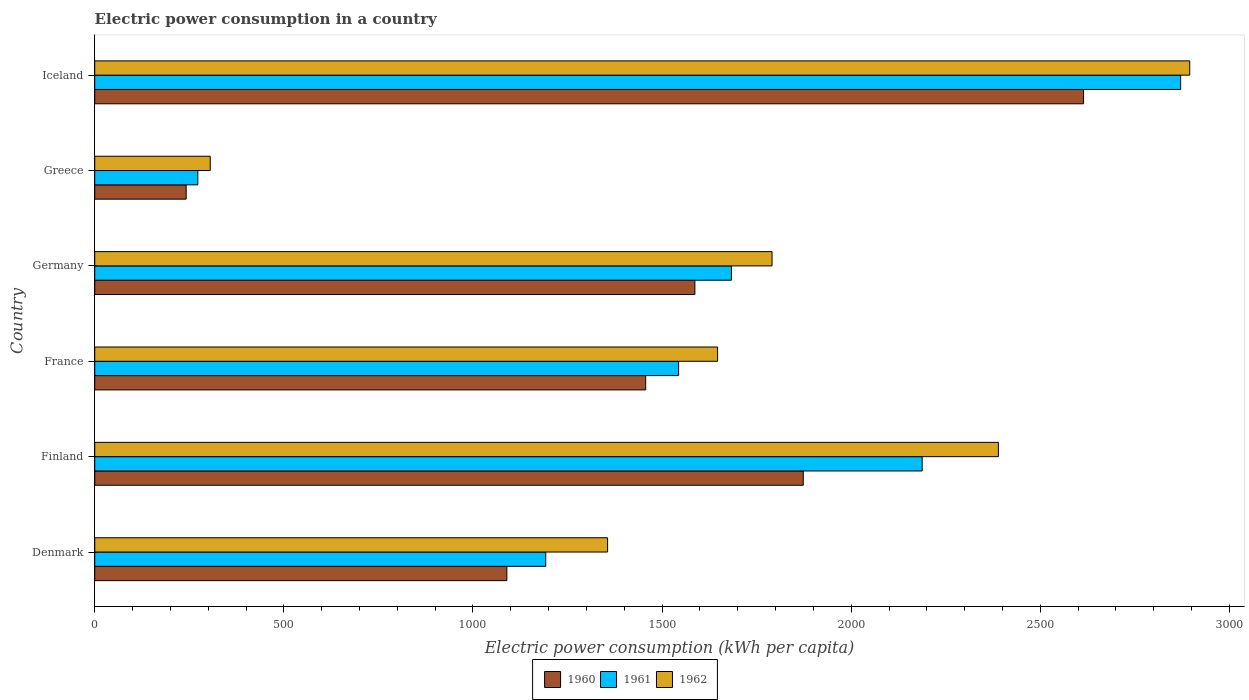How many different coloured bars are there?
Your answer should be very brief. 3. What is the label of the 4th group of bars from the top?
Keep it short and to the point. France. In how many cases, is the number of bars for a given country not equal to the number of legend labels?
Offer a very short reply. 0. What is the electric power consumption in in 1962 in Finland?
Your answer should be compact. 2389.21. Across all countries, what is the maximum electric power consumption in in 1961?
Ensure brevity in your answer.  2871.04. Across all countries, what is the minimum electric power consumption in in 1960?
Your answer should be compact. 241.73. In which country was the electric power consumption in in 1960 maximum?
Keep it short and to the point. Iceland. What is the total electric power consumption in in 1961 in the graph?
Your answer should be compact. 9750.76. What is the difference between the electric power consumption in in 1962 in Denmark and that in Greece?
Offer a very short reply. 1050.54. What is the difference between the electric power consumption in in 1960 in Denmark and the electric power consumption in in 1961 in Germany?
Ensure brevity in your answer.  -593.8. What is the average electric power consumption in in 1960 per country?
Keep it short and to the point. 1477.06. What is the difference between the electric power consumption in in 1960 and electric power consumption in in 1961 in Germany?
Provide a succinct answer. -96.67. What is the ratio of the electric power consumption in in 1962 in Greece to that in Iceland?
Your response must be concise. 0.11. What is the difference between the highest and the second highest electric power consumption in in 1961?
Offer a terse response. 683.42. What is the difference between the highest and the lowest electric power consumption in in 1961?
Your answer should be very brief. 2598.48. In how many countries, is the electric power consumption in in 1960 greater than the average electric power consumption in in 1960 taken over all countries?
Keep it short and to the point. 3. What does the 1st bar from the bottom in Greece represents?
Make the answer very short. 1960. Is it the case that in every country, the sum of the electric power consumption in in 1962 and electric power consumption in in 1960 is greater than the electric power consumption in in 1961?
Offer a terse response. Yes. How many bars are there?
Make the answer very short. 18. Are all the bars in the graph horizontal?
Make the answer very short. Yes. What is the difference between two consecutive major ticks on the X-axis?
Your response must be concise. 500. Are the values on the major ticks of X-axis written in scientific E-notation?
Your answer should be very brief. No. Does the graph contain grids?
Offer a terse response. No. Where does the legend appear in the graph?
Provide a short and direct response. Bottom center. What is the title of the graph?
Ensure brevity in your answer.  Electric power consumption in a country. What is the label or title of the X-axis?
Your answer should be compact. Electric power consumption (kWh per capita). What is the label or title of the Y-axis?
Offer a terse response. Country. What is the Electric power consumption (kWh per capita) in 1960 in Denmark?
Ensure brevity in your answer.  1089.61. What is the Electric power consumption (kWh per capita) of 1961 in Denmark?
Your answer should be very brief. 1192.41. What is the Electric power consumption (kWh per capita) in 1962 in Denmark?
Offer a very short reply. 1355.93. What is the Electric power consumption (kWh per capita) of 1960 in Finland?
Keep it short and to the point. 1873.29. What is the Electric power consumption (kWh per capita) in 1961 in Finland?
Give a very brief answer. 2187.62. What is the Electric power consumption (kWh per capita) in 1962 in Finland?
Offer a terse response. 2389.21. What is the Electric power consumption (kWh per capita) in 1960 in France?
Make the answer very short. 1456.69. What is the Electric power consumption (kWh per capita) of 1961 in France?
Keep it short and to the point. 1543.71. What is the Electric power consumption (kWh per capita) of 1962 in France?
Offer a terse response. 1646.83. What is the Electric power consumption (kWh per capita) in 1960 in Germany?
Keep it short and to the point. 1586.75. What is the Electric power consumption (kWh per capita) in 1961 in Germany?
Offer a terse response. 1683.41. What is the Electric power consumption (kWh per capita) of 1962 in Germany?
Your answer should be compact. 1790.69. What is the Electric power consumption (kWh per capita) of 1960 in Greece?
Provide a short and direct response. 241.73. What is the Electric power consumption (kWh per capita) in 1961 in Greece?
Your response must be concise. 272.56. What is the Electric power consumption (kWh per capita) of 1962 in Greece?
Give a very brief answer. 305.39. What is the Electric power consumption (kWh per capita) of 1960 in Iceland?
Your answer should be very brief. 2614.28. What is the Electric power consumption (kWh per capita) of 1961 in Iceland?
Make the answer very short. 2871.04. What is the Electric power consumption (kWh per capita) in 1962 in Iceland?
Offer a terse response. 2895.09. Across all countries, what is the maximum Electric power consumption (kWh per capita) in 1960?
Offer a very short reply. 2614.28. Across all countries, what is the maximum Electric power consumption (kWh per capita) of 1961?
Your response must be concise. 2871.04. Across all countries, what is the maximum Electric power consumption (kWh per capita) of 1962?
Your answer should be very brief. 2895.09. Across all countries, what is the minimum Electric power consumption (kWh per capita) of 1960?
Your response must be concise. 241.73. Across all countries, what is the minimum Electric power consumption (kWh per capita) in 1961?
Your answer should be very brief. 272.56. Across all countries, what is the minimum Electric power consumption (kWh per capita) in 1962?
Give a very brief answer. 305.39. What is the total Electric power consumption (kWh per capita) in 1960 in the graph?
Ensure brevity in your answer.  8862.36. What is the total Electric power consumption (kWh per capita) in 1961 in the graph?
Offer a terse response. 9750.76. What is the total Electric power consumption (kWh per capita) in 1962 in the graph?
Your answer should be very brief. 1.04e+04. What is the difference between the Electric power consumption (kWh per capita) of 1960 in Denmark and that in Finland?
Keep it short and to the point. -783.68. What is the difference between the Electric power consumption (kWh per capita) in 1961 in Denmark and that in Finland?
Offer a very short reply. -995.22. What is the difference between the Electric power consumption (kWh per capita) of 1962 in Denmark and that in Finland?
Ensure brevity in your answer.  -1033.28. What is the difference between the Electric power consumption (kWh per capita) of 1960 in Denmark and that in France?
Provide a short and direct response. -367.08. What is the difference between the Electric power consumption (kWh per capita) in 1961 in Denmark and that in France?
Ensure brevity in your answer.  -351.31. What is the difference between the Electric power consumption (kWh per capita) of 1962 in Denmark and that in France?
Provide a short and direct response. -290.9. What is the difference between the Electric power consumption (kWh per capita) in 1960 in Denmark and that in Germany?
Ensure brevity in your answer.  -497.14. What is the difference between the Electric power consumption (kWh per capita) of 1961 in Denmark and that in Germany?
Your answer should be compact. -491.01. What is the difference between the Electric power consumption (kWh per capita) of 1962 in Denmark and that in Germany?
Your answer should be compact. -434.76. What is the difference between the Electric power consumption (kWh per capita) of 1960 in Denmark and that in Greece?
Offer a very short reply. 847.89. What is the difference between the Electric power consumption (kWh per capita) of 1961 in Denmark and that in Greece?
Provide a succinct answer. 919.84. What is the difference between the Electric power consumption (kWh per capita) of 1962 in Denmark and that in Greece?
Ensure brevity in your answer.  1050.54. What is the difference between the Electric power consumption (kWh per capita) of 1960 in Denmark and that in Iceland?
Your answer should be very brief. -1524.67. What is the difference between the Electric power consumption (kWh per capita) of 1961 in Denmark and that in Iceland?
Ensure brevity in your answer.  -1678.64. What is the difference between the Electric power consumption (kWh per capita) in 1962 in Denmark and that in Iceland?
Make the answer very short. -1539.15. What is the difference between the Electric power consumption (kWh per capita) in 1960 in Finland and that in France?
Ensure brevity in your answer.  416.6. What is the difference between the Electric power consumption (kWh per capita) of 1961 in Finland and that in France?
Your answer should be compact. 643.91. What is the difference between the Electric power consumption (kWh per capita) in 1962 in Finland and that in France?
Provide a succinct answer. 742.38. What is the difference between the Electric power consumption (kWh per capita) in 1960 in Finland and that in Germany?
Give a very brief answer. 286.54. What is the difference between the Electric power consumption (kWh per capita) in 1961 in Finland and that in Germany?
Offer a terse response. 504.21. What is the difference between the Electric power consumption (kWh per capita) in 1962 in Finland and that in Germany?
Provide a succinct answer. 598.52. What is the difference between the Electric power consumption (kWh per capita) in 1960 in Finland and that in Greece?
Your answer should be very brief. 1631.57. What is the difference between the Electric power consumption (kWh per capita) in 1961 in Finland and that in Greece?
Offer a very short reply. 1915.06. What is the difference between the Electric power consumption (kWh per capita) of 1962 in Finland and that in Greece?
Provide a short and direct response. 2083.82. What is the difference between the Electric power consumption (kWh per capita) in 1960 in Finland and that in Iceland?
Provide a succinct answer. -740.99. What is the difference between the Electric power consumption (kWh per capita) of 1961 in Finland and that in Iceland?
Your answer should be very brief. -683.42. What is the difference between the Electric power consumption (kWh per capita) of 1962 in Finland and that in Iceland?
Offer a terse response. -505.88. What is the difference between the Electric power consumption (kWh per capita) in 1960 in France and that in Germany?
Make the answer very short. -130.06. What is the difference between the Electric power consumption (kWh per capita) in 1961 in France and that in Germany?
Offer a very short reply. -139.7. What is the difference between the Electric power consumption (kWh per capita) of 1962 in France and that in Germany?
Offer a terse response. -143.85. What is the difference between the Electric power consumption (kWh per capita) in 1960 in France and that in Greece?
Provide a short and direct response. 1214.97. What is the difference between the Electric power consumption (kWh per capita) of 1961 in France and that in Greece?
Offer a terse response. 1271.15. What is the difference between the Electric power consumption (kWh per capita) in 1962 in France and that in Greece?
Provide a succinct answer. 1341.44. What is the difference between the Electric power consumption (kWh per capita) in 1960 in France and that in Iceland?
Your answer should be very brief. -1157.59. What is the difference between the Electric power consumption (kWh per capita) in 1961 in France and that in Iceland?
Give a very brief answer. -1327.33. What is the difference between the Electric power consumption (kWh per capita) in 1962 in France and that in Iceland?
Provide a succinct answer. -1248.25. What is the difference between the Electric power consumption (kWh per capita) in 1960 in Germany and that in Greece?
Make the answer very short. 1345.02. What is the difference between the Electric power consumption (kWh per capita) in 1961 in Germany and that in Greece?
Give a very brief answer. 1410.85. What is the difference between the Electric power consumption (kWh per capita) in 1962 in Germany and that in Greece?
Give a very brief answer. 1485.3. What is the difference between the Electric power consumption (kWh per capita) in 1960 in Germany and that in Iceland?
Provide a succinct answer. -1027.53. What is the difference between the Electric power consumption (kWh per capita) of 1961 in Germany and that in Iceland?
Offer a terse response. -1187.63. What is the difference between the Electric power consumption (kWh per capita) in 1962 in Germany and that in Iceland?
Offer a very short reply. -1104.4. What is the difference between the Electric power consumption (kWh per capita) in 1960 in Greece and that in Iceland?
Your answer should be very brief. -2372.56. What is the difference between the Electric power consumption (kWh per capita) in 1961 in Greece and that in Iceland?
Provide a succinct answer. -2598.48. What is the difference between the Electric power consumption (kWh per capita) of 1962 in Greece and that in Iceland?
Give a very brief answer. -2589.7. What is the difference between the Electric power consumption (kWh per capita) of 1960 in Denmark and the Electric power consumption (kWh per capita) of 1961 in Finland?
Ensure brevity in your answer.  -1098.01. What is the difference between the Electric power consumption (kWh per capita) in 1960 in Denmark and the Electric power consumption (kWh per capita) in 1962 in Finland?
Offer a terse response. -1299.6. What is the difference between the Electric power consumption (kWh per capita) of 1961 in Denmark and the Electric power consumption (kWh per capita) of 1962 in Finland?
Ensure brevity in your answer.  -1196.8. What is the difference between the Electric power consumption (kWh per capita) in 1960 in Denmark and the Electric power consumption (kWh per capita) in 1961 in France?
Provide a short and direct response. -454.1. What is the difference between the Electric power consumption (kWh per capita) in 1960 in Denmark and the Electric power consumption (kWh per capita) in 1962 in France?
Offer a terse response. -557.22. What is the difference between the Electric power consumption (kWh per capita) of 1961 in Denmark and the Electric power consumption (kWh per capita) of 1962 in France?
Ensure brevity in your answer.  -454.43. What is the difference between the Electric power consumption (kWh per capita) of 1960 in Denmark and the Electric power consumption (kWh per capita) of 1961 in Germany?
Make the answer very short. -593.8. What is the difference between the Electric power consumption (kWh per capita) in 1960 in Denmark and the Electric power consumption (kWh per capita) in 1962 in Germany?
Your answer should be compact. -701.07. What is the difference between the Electric power consumption (kWh per capita) of 1961 in Denmark and the Electric power consumption (kWh per capita) of 1962 in Germany?
Your response must be concise. -598.28. What is the difference between the Electric power consumption (kWh per capita) in 1960 in Denmark and the Electric power consumption (kWh per capita) in 1961 in Greece?
Make the answer very short. 817.05. What is the difference between the Electric power consumption (kWh per capita) of 1960 in Denmark and the Electric power consumption (kWh per capita) of 1962 in Greece?
Keep it short and to the point. 784.22. What is the difference between the Electric power consumption (kWh per capita) of 1961 in Denmark and the Electric power consumption (kWh per capita) of 1962 in Greece?
Make the answer very short. 887.02. What is the difference between the Electric power consumption (kWh per capita) in 1960 in Denmark and the Electric power consumption (kWh per capita) in 1961 in Iceland?
Provide a succinct answer. -1781.43. What is the difference between the Electric power consumption (kWh per capita) in 1960 in Denmark and the Electric power consumption (kWh per capita) in 1962 in Iceland?
Offer a very short reply. -1805.47. What is the difference between the Electric power consumption (kWh per capita) of 1961 in Denmark and the Electric power consumption (kWh per capita) of 1962 in Iceland?
Ensure brevity in your answer.  -1702.68. What is the difference between the Electric power consumption (kWh per capita) of 1960 in Finland and the Electric power consumption (kWh per capita) of 1961 in France?
Ensure brevity in your answer.  329.58. What is the difference between the Electric power consumption (kWh per capita) in 1960 in Finland and the Electric power consumption (kWh per capita) in 1962 in France?
Your response must be concise. 226.46. What is the difference between the Electric power consumption (kWh per capita) in 1961 in Finland and the Electric power consumption (kWh per capita) in 1962 in France?
Your answer should be very brief. 540.79. What is the difference between the Electric power consumption (kWh per capita) in 1960 in Finland and the Electric power consumption (kWh per capita) in 1961 in Germany?
Keep it short and to the point. 189.88. What is the difference between the Electric power consumption (kWh per capita) of 1960 in Finland and the Electric power consumption (kWh per capita) of 1962 in Germany?
Keep it short and to the point. 82.61. What is the difference between the Electric power consumption (kWh per capita) in 1961 in Finland and the Electric power consumption (kWh per capita) in 1962 in Germany?
Offer a terse response. 396.94. What is the difference between the Electric power consumption (kWh per capita) of 1960 in Finland and the Electric power consumption (kWh per capita) of 1961 in Greece?
Your response must be concise. 1600.73. What is the difference between the Electric power consumption (kWh per capita) of 1960 in Finland and the Electric power consumption (kWh per capita) of 1962 in Greece?
Keep it short and to the point. 1567.9. What is the difference between the Electric power consumption (kWh per capita) of 1961 in Finland and the Electric power consumption (kWh per capita) of 1962 in Greece?
Your response must be concise. 1882.23. What is the difference between the Electric power consumption (kWh per capita) of 1960 in Finland and the Electric power consumption (kWh per capita) of 1961 in Iceland?
Your answer should be compact. -997.75. What is the difference between the Electric power consumption (kWh per capita) in 1960 in Finland and the Electric power consumption (kWh per capita) in 1962 in Iceland?
Your answer should be compact. -1021.79. What is the difference between the Electric power consumption (kWh per capita) in 1961 in Finland and the Electric power consumption (kWh per capita) in 1962 in Iceland?
Offer a very short reply. -707.46. What is the difference between the Electric power consumption (kWh per capita) in 1960 in France and the Electric power consumption (kWh per capita) in 1961 in Germany?
Your answer should be very brief. -226.72. What is the difference between the Electric power consumption (kWh per capita) of 1960 in France and the Electric power consumption (kWh per capita) of 1962 in Germany?
Your response must be concise. -333.99. What is the difference between the Electric power consumption (kWh per capita) in 1961 in France and the Electric power consumption (kWh per capita) in 1962 in Germany?
Make the answer very short. -246.98. What is the difference between the Electric power consumption (kWh per capita) of 1960 in France and the Electric power consumption (kWh per capita) of 1961 in Greece?
Keep it short and to the point. 1184.13. What is the difference between the Electric power consumption (kWh per capita) in 1960 in France and the Electric power consumption (kWh per capita) in 1962 in Greece?
Offer a terse response. 1151.3. What is the difference between the Electric power consumption (kWh per capita) in 1961 in France and the Electric power consumption (kWh per capita) in 1962 in Greece?
Provide a succinct answer. 1238.32. What is the difference between the Electric power consumption (kWh per capita) in 1960 in France and the Electric power consumption (kWh per capita) in 1961 in Iceland?
Offer a very short reply. -1414.35. What is the difference between the Electric power consumption (kWh per capita) in 1960 in France and the Electric power consumption (kWh per capita) in 1962 in Iceland?
Give a very brief answer. -1438.39. What is the difference between the Electric power consumption (kWh per capita) of 1961 in France and the Electric power consumption (kWh per capita) of 1962 in Iceland?
Your answer should be very brief. -1351.37. What is the difference between the Electric power consumption (kWh per capita) of 1960 in Germany and the Electric power consumption (kWh per capita) of 1961 in Greece?
Provide a succinct answer. 1314.19. What is the difference between the Electric power consumption (kWh per capita) of 1960 in Germany and the Electric power consumption (kWh per capita) of 1962 in Greece?
Keep it short and to the point. 1281.36. What is the difference between the Electric power consumption (kWh per capita) in 1961 in Germany and the Electric power consumption (kWh per capita) in 1962 in Greece?
Provide a succinct answer. 1378.03. What is the difference between the Electric power consumption (kWh per capita) in 1960 in Germany and the Electric power consumption (kWh per capita) in 1961 in Iceland?
Give a very brief answer. -1284.29. What is the difference between the Electric power consumption (kWh per capita) of 1960 in Germany and the Electric power consumption (kWh per capita) of 1962 in Iceland?
Keep it short and to the point. -1308.34. What is the difference between the Electric power consumption (kWh per capita) of 1961 in Germany and the Electric power consumption (kWh per capita) of 1962 in Iceland?
Your answer should be very brief. -1211.67. What is the difference between the Electric power consumption (kWh per capita) of 1960 in Greece and the Electric power consumption (kWh per capita) of 1961 in Iceland?
Provide a succinct answer. -2629.32. What is the difference between the Electric power consumption (kWh per capita) of 1960 in Greece and the Electric power consumption (kWh per capita) of 1962 in Iceland?
Keep it short and to the point. -2653.36. What is the difference between the Electric power consumption (kWh per capita) in 1961 in Greece and the Electric power consumption (kWh per capita) in 1962 in Iceland?
Keep it short and to the point. -2622.52. What is the average Electric power consumption (kWh per capita) of 1960 per country?
Make the answer very short. 1477.06. What is the average Electric power consumption (kWh per capita) of 1961 per country?
Offer a very short reply. 1625.13. What is the average Electric power consumption (kWh per capita) in 1962 per country?
Your response must be concise. 1730.52. What is the difference between the Electric power consumption (kWh per capita) of 1960 and Electric power consumption (kWh per capita) of 1961 in Denmark?
Offer a terse response. -102.79. What is the difference between the Electric power consumption (kWh per capita) of 1960 and Electric power consumption (kWh per capita) of 1962 in Denmark?
Keep it short and to the point. -266.32. What is the difference between the Electric power consumption (kWh per capita) in 1961 and Electric power consumption (kWh per capita) in 1962 in Denmark?
Provide a succinct answer. -163.53. What is the difference between the Electric power consumption (kWh per capita) in 1960 and Electric power consumption (kWh per capita) in 1961 in Finland?
Provide a succinct answer. -314.33. What is the difference between the Electric power consumption (kWh per capita) of 1960 and Electric power consumption (kWh per capita) of 1962 in Finland?
Offer a very short reply. -515.92. What is the difference between the Electric power consumption (kWh per capita) in 1961 and Electric power consumption (kWh per capita) in 1962 in Finland?
Your answer should be very brief. -201.59. What is the difference between the Electric power consumption (kWh per capita) in 1960 and Electric power consumption (kWh per capita) in 1961 in France?
Your response must be concise. -87.02. What is the difference between the Electric power consumption (kWh per capita) of 1960 and Electric power consumption (kWh per capita) of 1962 in France?
Offer a very short reply. -190.14. What is the difference between the Electric power consumption (kWh per capita) in 1961 and Electric power consumption (kWh per capita) in 1962 in France?
Make the answer very short. -103.12. What is the difference between the Electric power consumption (kWh per capita) of 1960 and Electric power consumption (kWh per capita) of 1961 in Germany?
Provide a succinct answer. -96.67. What is the difference between the Electric power consumption (kWh per capita) of 1960 and Electric power consumption (kWh per capita) of 1962 in Germany?
Your answer should be very brief. -203.94. What is the difference between the Electric power consumption (kWh per capita) in 1961 and Electric power consumption (kWh per capita) in 1962 in Germany?
Your response must be concise. -107.27. What is the difference between the Electric power consumption (kWh per capita) of 1960 and Electric power consumption (kWh per capita) of 1961 in Greece?
Offer a terse response. -30.84. What is the difference between the Electric power consumption (kWh per capita) of 1960 and Electric power consumption (kWh per capita) of 1962 in Greece?
Offer a terse response. -63.66. What is the difference between the Electric power consumption (kWh per capita) in 1961 and Electric power consumption (kWh per capita) in 1962 in Greece?
Keep it short and to the point. -32.83. What is the difference between the Electric power consumption (kWh per capita) of 1960 and Electric power consumption (kWh per capita) of 1961 in Iceland?
Offer a terse response. -256.76. What is the difference between the Electric power consumption (kWh per capita) of 1960 and Electric power consumption (kWh per capita) of 1962 in Iceland?
Your answer should be compact. -280.8. What is the difference between the Electric power consumption (kWh per capita) in 1961 and Electric power consumption (kWh per capita) in 1962 in Iceland?
Offer a very short reply. -24.04. What is the ratio of the Electric power consumption (kWh per capita) of 1960 in Denmark to that in Finland?
Provide a succinct answer. 0.58. What is the ratio of the Electric power consumption (kWh per capita) of 1961 in Denmark to that in Finland?
Make the answer very short. 0.55. What is the ratio of the Electric power consumption (kWh per capita) of 1962 in Denmark to that in Finland?
Make the answer very short. 0.57. What is the ratio of the Electric power consumption (kWh per capita) of 1960 in Denmark to that in France?
Keep it short and to the point. 0.75. What is the ratio of the Electric power consumption (kWh per capita) in 1961 in Denmark to that in France?
Provide a short and direct response. 0.77. What is the ratio of the Electric power consumption (kWh per capita) in 1962 in Denmark to that in France?
Make the answer very short. 0.82. What is the ratio of the Electric power consumption (kWh per capita) of 1960 in Denmark to that in Germany?
Provide a succinct answer. 0.69. What is the ratio of the Electric power consumption (kWh per capita) in 1961 in Denmark to that in Germany?
Keep it short and to the point. 0.71. What is the ratio of the Electric power consumption (kWh per capita) of 1962 in Denmark to that in Germany?
Your answer should be very brief. 0.76. What is the ratio of the Electric power consumption (kWh per capita) in 1960 in Denmark to that in Greece?
Give a very brief answer. 4.51. What is the ratio of the Electric power consumption (kWh per capita) of 1961 in Denmark to that in Greece?
Your answer should be compact. 4.37. What is the ratio of the Electric power consumption (kWh per capita) in 1962 in Denmark to that in Greece?
Your answer should be compact. 4.44. What is the ratio of the Electric power consumption (kWh per capita) of 1960 in Denmark to that in Iceland?
Your answer should be very brief. 0.42. What is the ratio of the Electric power consumption (kWh per capita) in 1961 in Denmark to that in Iceland?
Offer a very short reply. 0.42. What is the ratio of the Electric power consumption (kWh per capita) of 1962 in Denmark to that in Iceland?
Ensure brevity in your answer.  0.47. What is the ratio of the Electric power consumption (kWh per capita) of 1960 in Finland to that in France?
Provide a short and direct response. 1.29. What is the ratio of the Electric power consumption (kWh per capita) in 1961 in Finland to that in France?
Offer a very short reply. 1.42. What is the ratio of the Electric power consumption (kWh per capita) of 1962 in Finland to that in France?
Provide a short and direct response. 1.45. What is the ratio of the Electric power consumption (kWh per capita) in 1960 in Finland to that in Germany?
Provide a short and direct response. 1.18. What is the ratio of the Electric power consumption (kWh per capita) in 1961 in Finland to that in Germany?
Ensure brevity in your answer.  1.3. What is the ratio of the Electric power consumption (kWh per capita) in 1962 in Finland to that in Germany?
Your response must be concise. 1.33. What is the ratio of the Electric power consumption (kWh per capita) of 1960 in Finland to that in Greece?
Keep it short and to the point. 7.75. What is the ratio of the Electric power consumption (kWh per capita) in 1961 in Finland to that in Greece?
Your answer should be compact. 8.03. What is the ratio of the Electric power consumption (kWh per capita) in 1962 in Finland to that in Greece?
Your answer should be compact. 7.82. What is the ratio of the Electric power consumption (kWh per capita) in 1960 in Finland to that in Iceland?
Make the answer very short. 0.72. What is the ratio of the Electric power consumption (kWh per capita) of 1961 in Finland to that in Iceland?
Make the answer very short. 0.76. What is the ratio of the Electric power consumption (kWh per capita) of 1962 in Finland to that in Iceland?
Give a very brief answer. 0.83. What is the ratio of the Electric power consumption (kWh per capita) of 1960 in France to that in Germany?
Offer a terse response. 0.92. What is the ratio of the Electric power consumption (kWh per capita) in 1961 in France to that in Germany?
Offer a terse response. 0.92. What is the ratio of the Electric power consumption (kWh per capita) of 1962 in France to that in Germany?
Your answer should be compact. 0.92. What is the ratio of the Electric power consumption (kWh per capita) of 1960 in France to that in Greece?
Provide a short and direct response. 6.03. What is the ratio of the Electric power consumption (kWh per capita) of 1961 in France to that in Greece?
Provide a succinct answer. 5.66. What is the ratio of the Electric power consumption (kWh per capita) in 1962 in France to that in Greece?
Your response must be concise. 5.39. What is the ratio of the Electric power consumption (kWh per capita) in 1960 in France to that in Iceland?
Make the answer very short. 0.56. What is the ratio of the Electric power consumption (kWh per capita) of 1961 in France to that in Iceland?
Give a very brief answer. 0.54. What is the ratio of the Electric power consumption (kWh per capita) in 1962 in France to that in Iceland?
Offer a very short reply. 0.57. What is the ratio of the Electric power consumption (kWh per capita) in 1960 in Germany to that in Greece?
Make the answer very short. 6.56. What is the ratio of the Electric power consumption (kWh per capita) of 1961 in Germany to that in Greece?
Your answer should be compact. 6.18. What is the ratio of the Electric power consumption (kWh per capita) of 1962 in Germany to that in Greece?
Offer a very short reply. 5.86. What is the ratio of the Electric power consumption (kWh per capita) of 1960 in Germany to that in Iceland?
Ensure brevity in your answer.  0.61. What is the ratio of the Electric power consumption (kWh per capita) of 1961 in Germany to that in Iceland?
Provide a short and direct response. 0.59. What is the ratio of the Electric power consumption (kWh per capita) in 1962 in Germany to that in Iceland?
Give a very brief answer. 0.62. What is the ratio of the Electric power consumption (kWh per capita) in 1960 in Greece to that in Iceland?
Provide a short and direct response. 0.09. What is the ratio of the Electric power consumption (kWh per capita) in 1961 in Greece to that in Iceland?
Provide a succinct answer. 0.09. What is the ratio of the Electric power consumption (kWh per capita) in 1962 in Greece to that in Iceland?
Your answer should be very brief. 0.11. What is the difference between the highest and the second highest Electric power consumption (kWh per capita) of 1960?
Offer a terse response. 740.99. What is the difference between the highest and the second highest Electric power consumption (kWh per capita) of 1961?
Offer a very short reply. 683.42. What is the difference between the highest and the second highest Electric power consumption (kWh per capita) of 1962?
Make the answer very short. 505.88. What is the difference between the highest and the lowest Electric power consumption (kWh per capita) of 1960?
Your response must be concise. 2372.56. What is the difference between the highest and the lowest Electric power consumption (kWh per capita) of 1961?
Give a very brief answer. 2598.48. What is the difference between the highest and the lowest Electric power consumption (kWh per capita) in 1962?
Your answer should be very brief. 2589.7. 